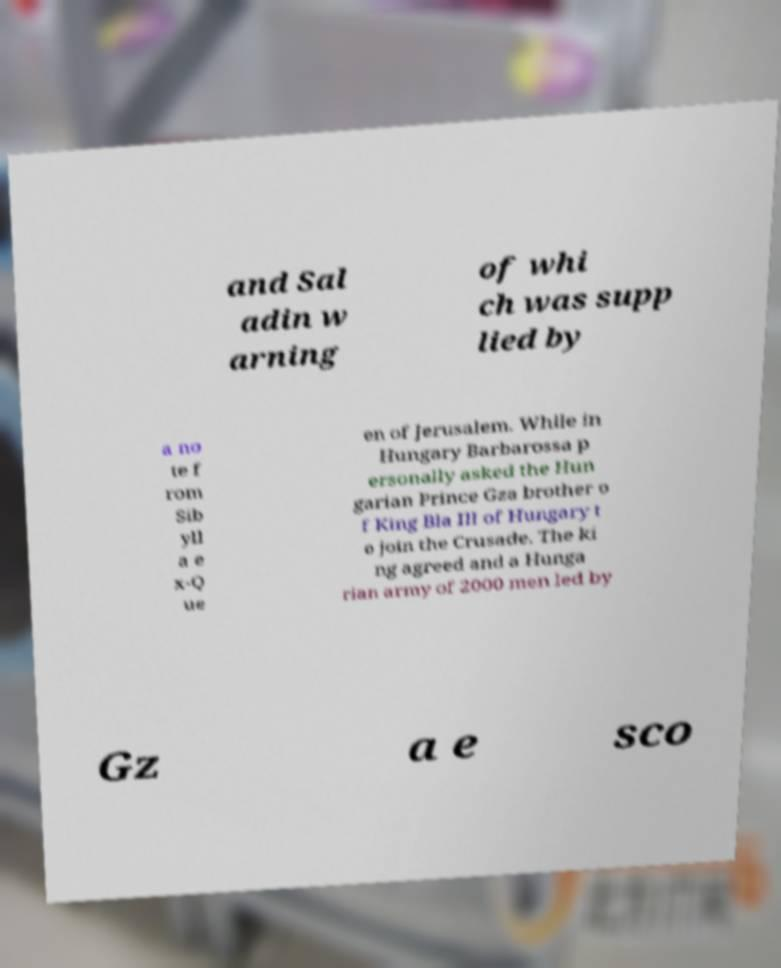Could you assist in decoding the text presented in this image and type it out clearly? and Sal adin w arning of whi ch was supp lied by a no te f rom Sib yll a e x-Q ue en of Jerusalem. While in Hungary Barbarossa p ersonally asked the Hun garian Prince Gza brother o f King Bla III of Hungary t o join the Crusade. The ki ng agreed and a Hunga rian army of 2000 men led by Gz a e sco 